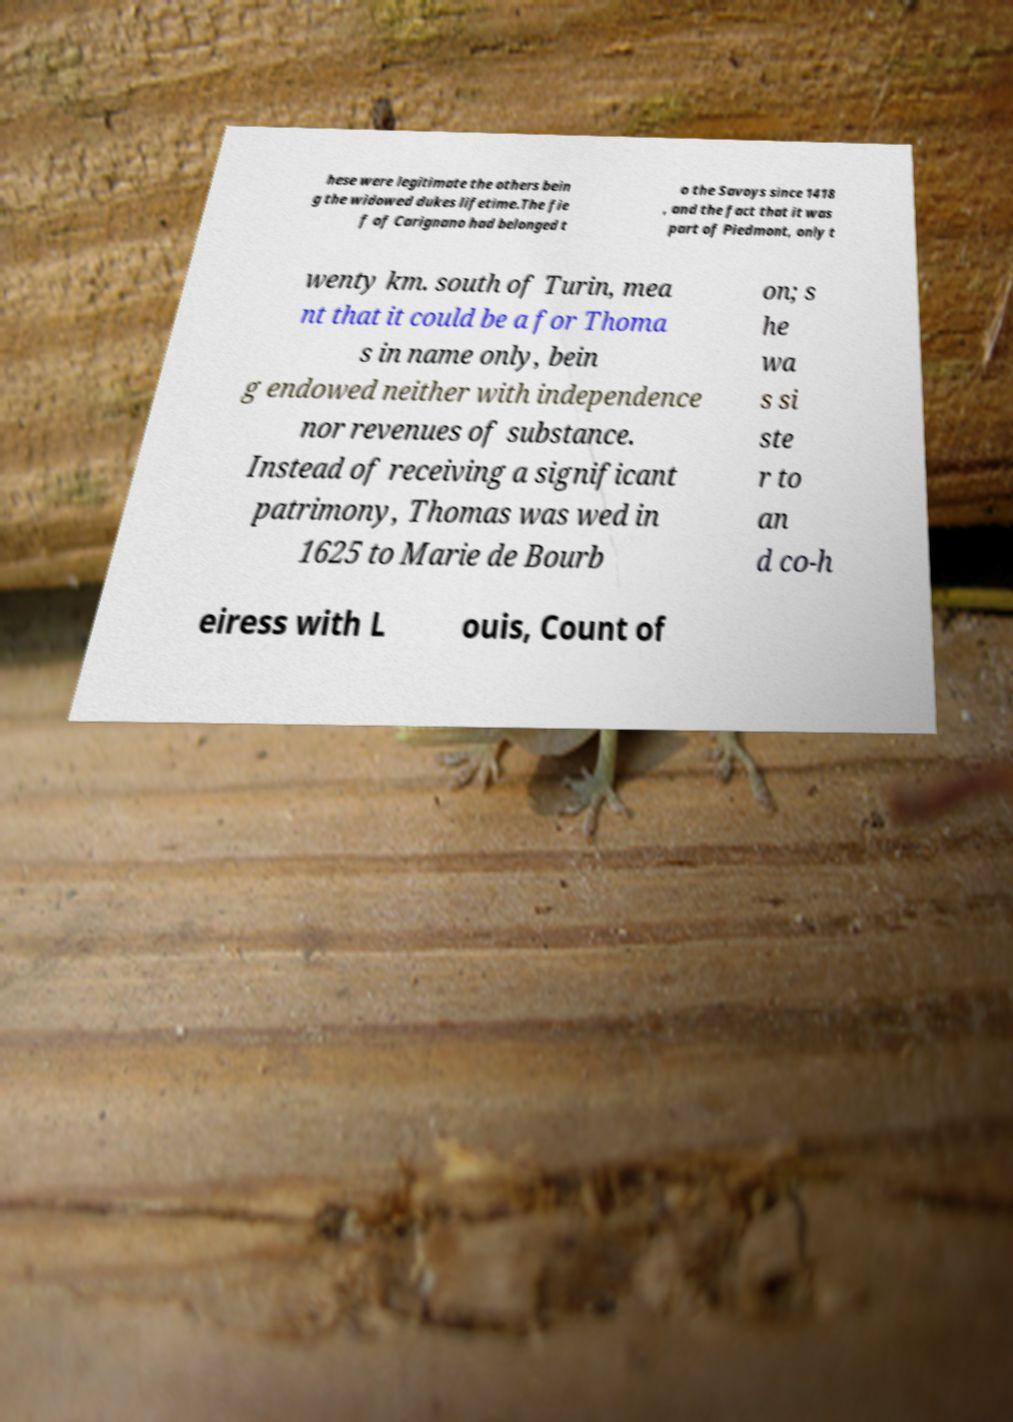Could you assist in decoding the text presented in this image and type it out clearly? hese were legitimate the others bein g the widowed dukes lifetime.The fie f of Carignano had belonged t o the Savoys since 1418 , and the fact that it was part of Piedmont, only t wenty km. south of Turin, mea nt that it could be a for Thoma s in name only, bein g endowed neither with independence nor revenues of substance. Instead of receiving a significant patrimony, Thomas was wed in 1625 to Marie de Bourb on; s he wa s si ste r to an d co-h eiress with L ouis, Count of 